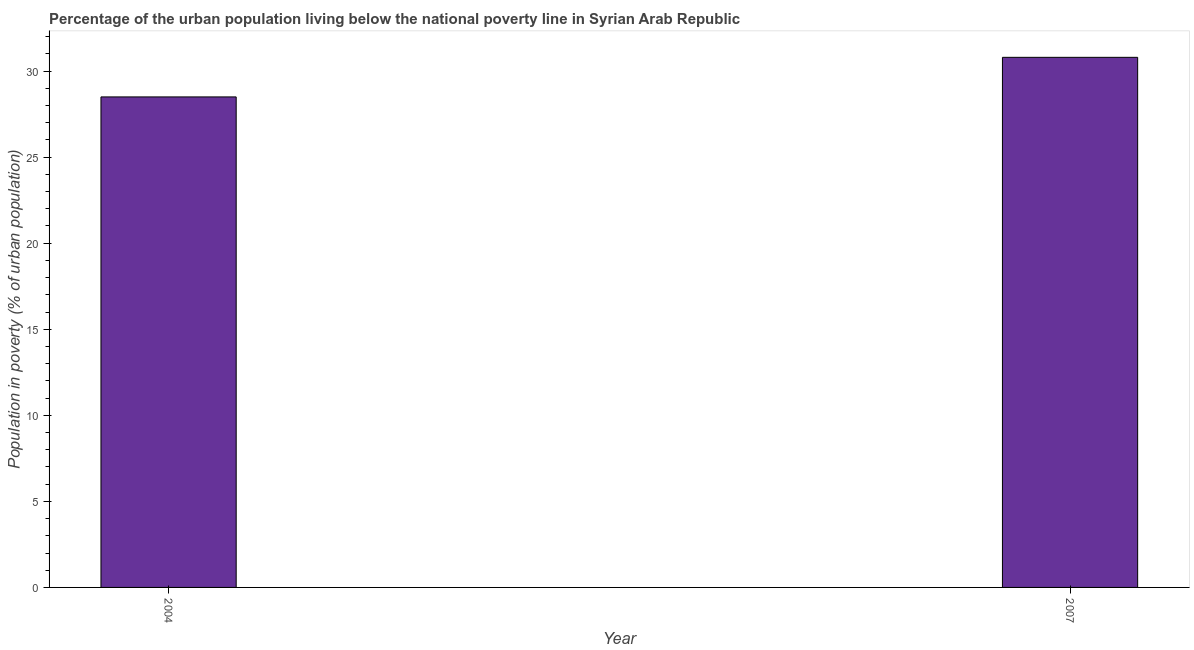Does the graph contain grids?
Your response must be concise. No. What is the title of the graph?
Your response must be concise. Percentage of the urban population living below the national poverty line in Syrian Arab Republic. What is the label or title of the Y-axis?
Make the answer very short. Population in poverty (% of urban population). Across all years, what is the maximum percentage of urban population living below poverty line?
Your answer should be compact. 30.8. In which year was the percentage of urban population living below poverty line maximum?
Make the answer very short. 2007. What is the sum of the percentage of urban population living below poverty line?
Offer a very short reply. 59.3. What is the average percentage of urban population living below poverty line per year?
Make the answer very short. 29.65. What is the median percentage of urban population living below poverty line?
Offer a very short reply. 29.65. In how many years, is the percentage of urban population living below poverty line greater than 21 %?
Offer a terse response. 2. What is the ratio of the percentage of urban population living below poverty line in 2004 to that in 2007?
Ensure brevity in your answer.  0.93. Is the percentage of urban population living below poverty line in 2004 less than that in 2007?
Offer a very short reply. Yes. Are all the bars in the graph horizontal?
Ensure brevity in your answer.  No. How many years are there in the graph?
Provide a short and direct response. 2. Are the values on the major ticks of Y-axis written in scientific E-notation?
Offer a very short reply. No. What is the Population in poverty (% of urban population) in 2004?
Keep it short and to the point. 28.5. What is the Population in poverty (% of urban population) in 2007?
Offer a terse response. 30.8. What is the difference between the Population in poverty (% of urban population) in 2004 and 2007?
Your response must be concise. -2.3. What is the ratio of the Population in poverty (% of urban population) in 2004 to that in 2007?
Provide a short and direct response. 0.93. 